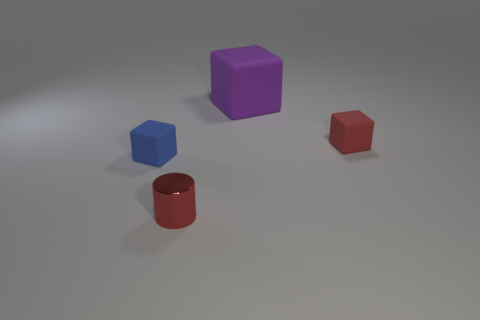Subtract all big rubber cubes. How many cubes are left? 2 Subtract all blue blocks. How many blocks are left? 2 Subtract 3 cubes. How many cubes are left? 0 Add 1 red objects. How many objects exist? 5 Subtract all cylinders. How many objects are left? 3 Subtract all purple rubber objects. Subtract all tiny red balls. How many objects are left? 3 Add 2 tiny blue rubber cubes. How many tiny blue rubber cubes are left? 3 Add 1 green blocks. How many green blocks exist? 1 Subtract 0 blue cylinders. How many objects are left? 4 Subtract all brown cubes. Subtract all blue cylinders. How many cubes are left? 3 